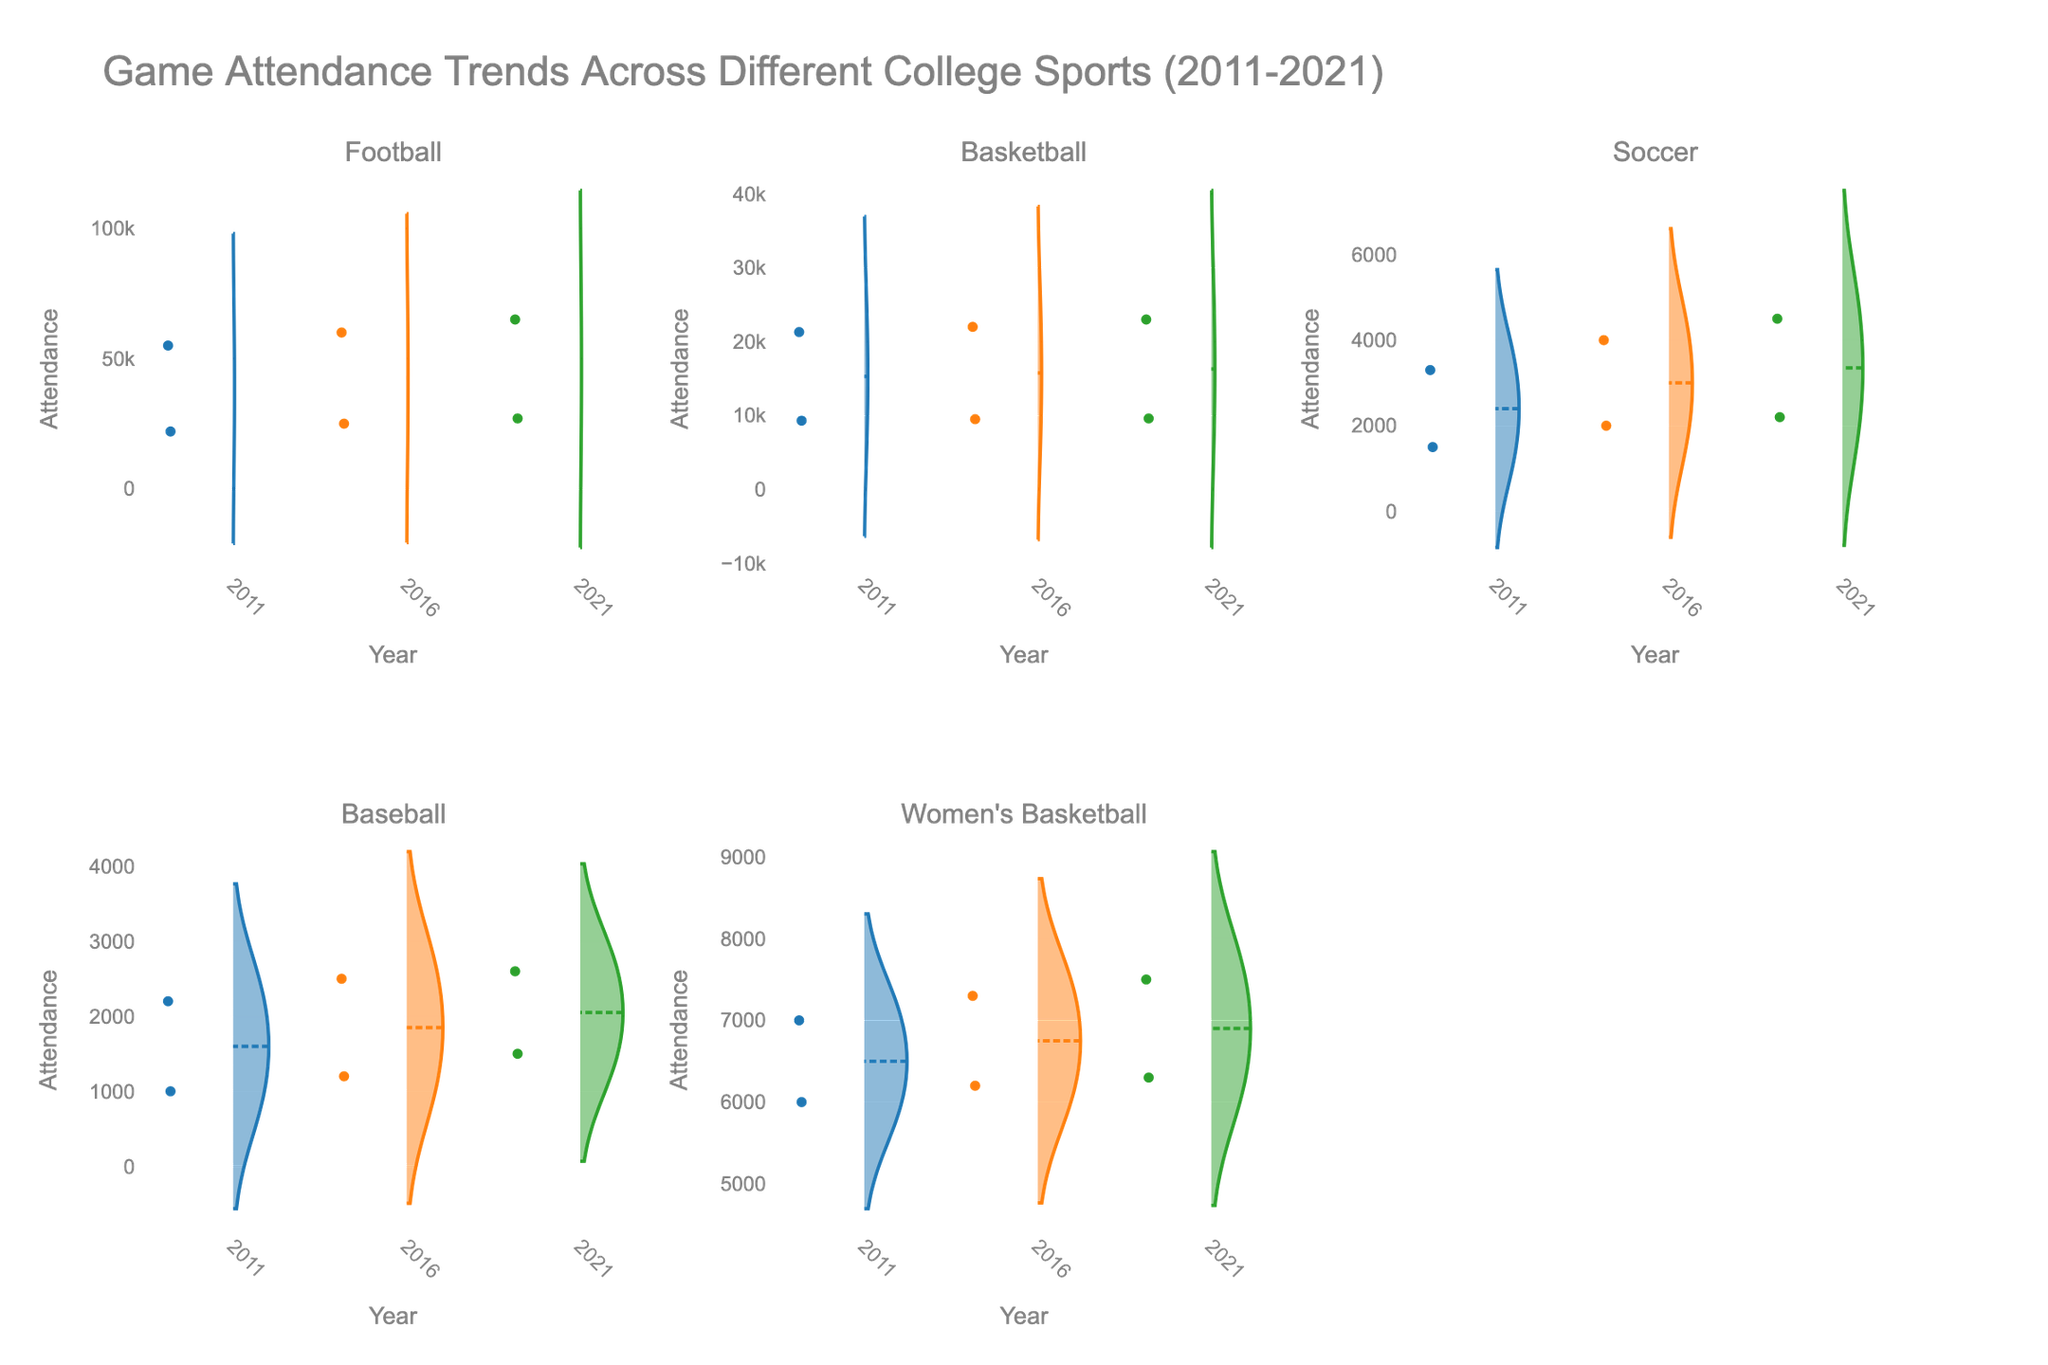what is the title of the figure? The figure's title is usually at the top center and provides a brief description. By looking there, you can see the title mentioning trends in sports attendance.
Answer: Game Attendance Trends Across Different College Sports (2011-2021) How many sports are presented in the figure's subplots? The figure has subplots for each sport, labeled with their names. By counting these labels, you can determine the number of sports.
Answer: 5 What sport had the highest attendance in 2021? For each sport's subplot, you can see the distribution of attendance values for 2021. The highest attendance value in 2021 appears in the subplot of Football.
Answer: Football How did the attendance for Women's Basketball at Duke University change from 2011 to 2021? By comparing the points for Duke University in the Women's Basketball subplot for the years 2011 and 2021, you can see the shift in attendance values.
Answer: Increased Which sport had the lowest average attendance in 2011? By examining the violin plots for 2011 across all sports, you can look for the sport with the lowest median line or overall low attendance values. Soccer for Duke University shows the lowest attendance.
Answer: Soccer In which year did Baseball at Duke University see the biggest change in attendance? By looking at the Volleyball subplot for changes in Duke University's attendance points across the years, identify the year with the largest difference in values.
Answer: 2021 Which sport shows a significant increase in attendance at the University of North Carolina from 2011 to 2021? Comparing violin plots for the University of North Carolina in each sport's subplot between 2011 and 2021, the rise in attendance is most visible in Football.
Answer: Football How does the attendance distribution for Soccer compare between Duke University and North Carolina State University in 2021? By comparing the 2021 violin plot for both universities within the Soccer subplot, see if Duke University's attendance is lower but closer together, while North Carolina State University's is higher and more spread out.
Answer: Duke University lower, North Carolina State University higher What is the median attendance for Basketball at Duke University in 2016? The median attendance can be identified by the mean line on the 2016 violin plot for Basketball at Duke University. Examining this line, you find the value.
Answer: 9500 